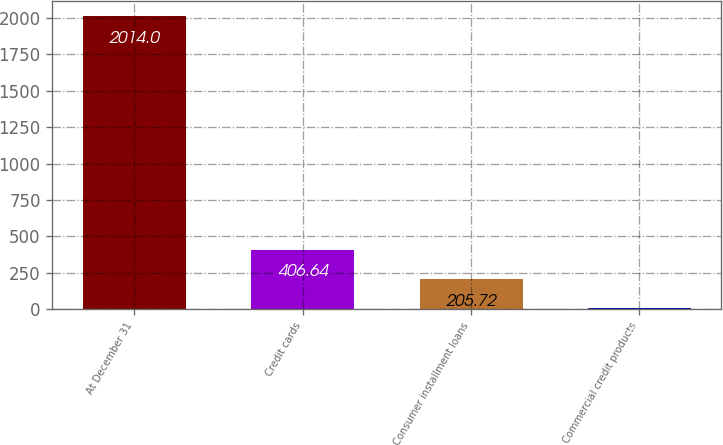Convert chart to OTSL. <chart><loc_0><loc_0><loc_500><loc_500><bar_chart><fcel>At December 31<fcel>Credit cards<fcel>Consumer installment loans<fcel>Commercial credit products<nl><fcel>2014<fcel>406.64<fcel>205.72<fcel>4.8<nl></chart> 